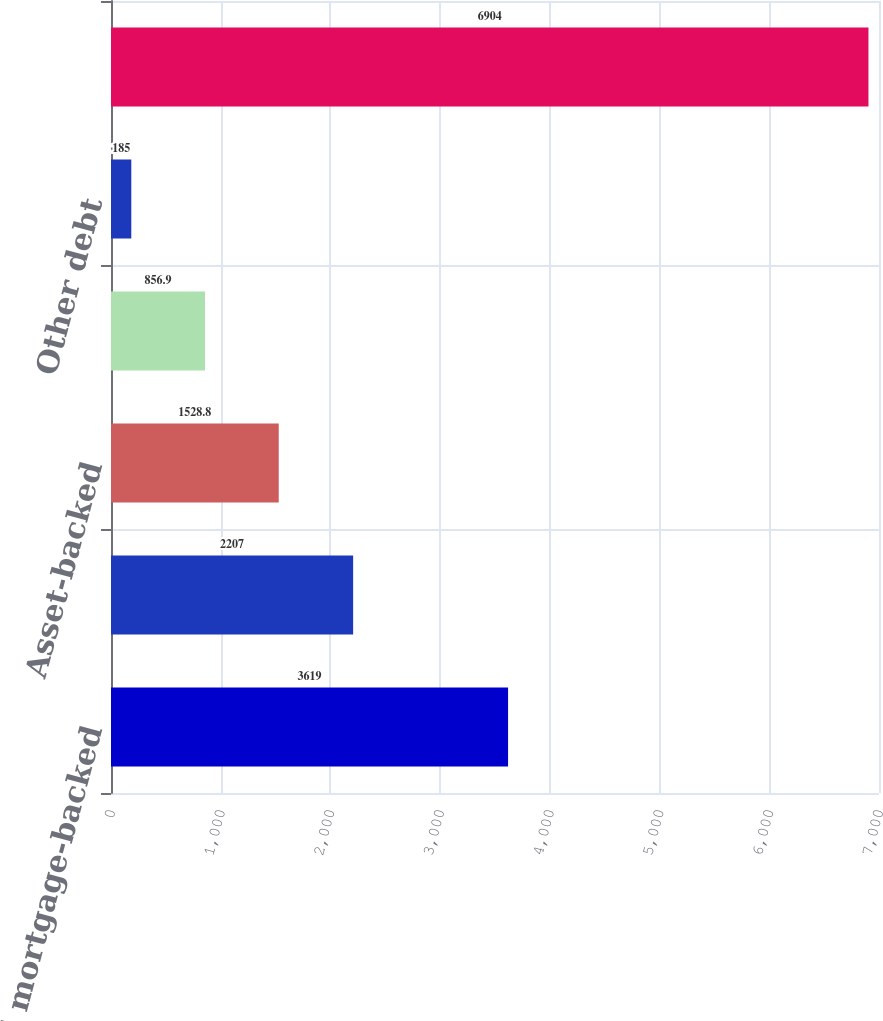Convert chart. <chart><loc_0><loc_0><loc_500><loc_500><bar_chart><fcel>Residential mortgage-backed<fcel>Commercial mortgage-backed<fcel>Asset-backed<fcel>State and municipal<fcel>Other debt<fcel>Total<nl><fcel>3619<fcel>2207<fcel>1528.8<fcel>856.9<fcel>185<fcel>6904<nl></chart> 